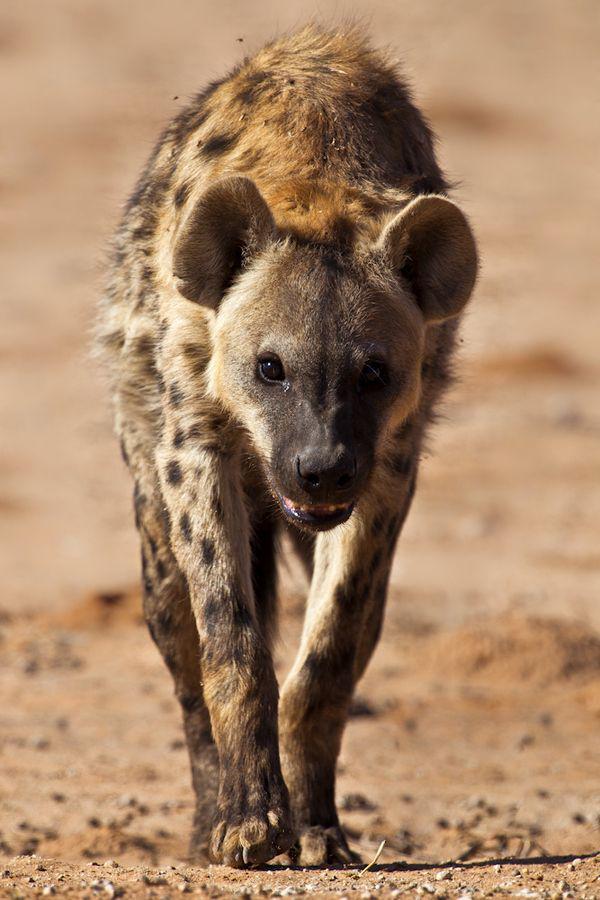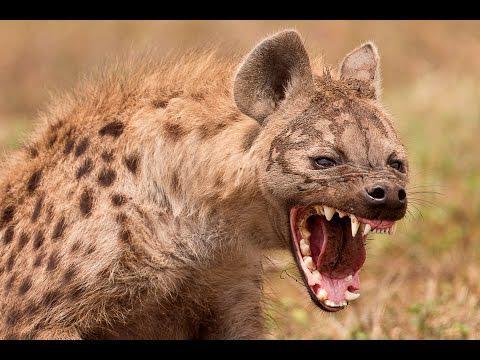The first image is the image on the left, the second image is the image on the right. Analyze the images presented: Is the assertion "The left image contains no more than one hyena." valid? Answer yes or no. Yes. The first image is the image on the left, the second image is the image on the right. For the images shown, is this caption "There is a species other than a hyena in at least one of the images." true? Answer yes or no. No. 